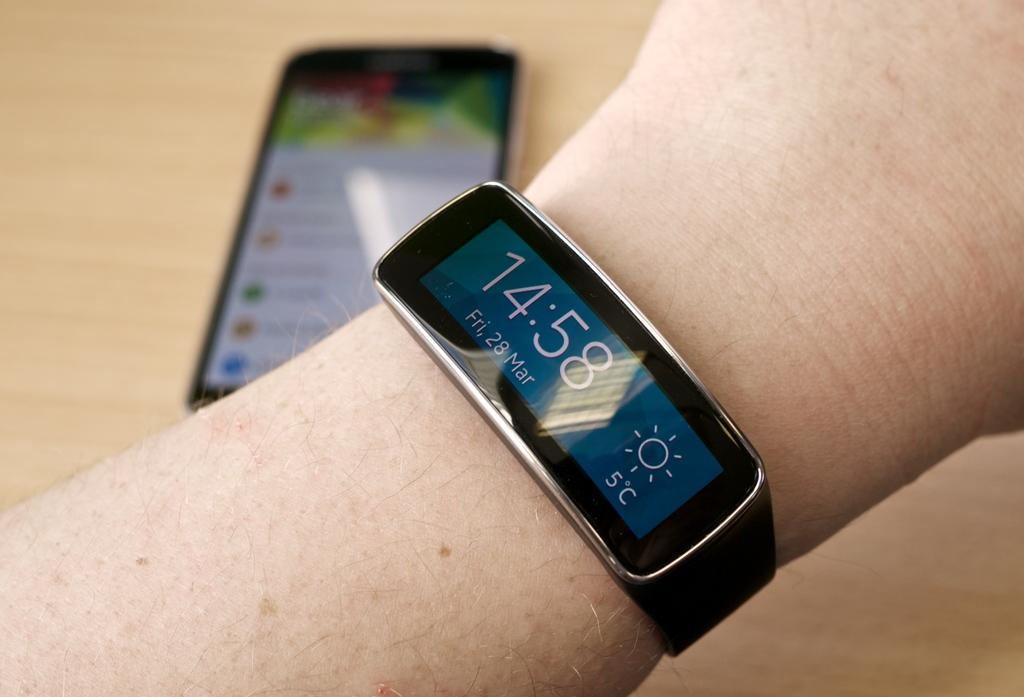<image>
Write a terse but informative summary of the picture. A watch shows the time of 14:58 and the temperature of 5 C. 